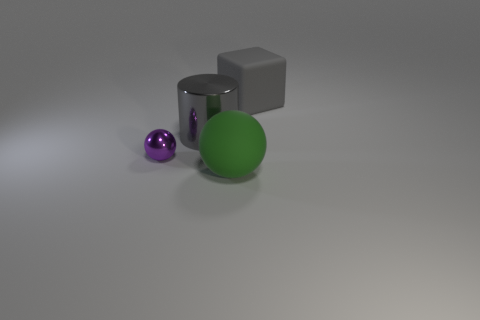Add 1 big gray matte cubes. How many objects exist? 5 Subtract all cylinders. How many objects are left? 3 Add 2 gray matte cubes. How many gray matte cubes are left? 3 Add 1 tiny things. How many tiny things exist? 2 Subtract 0 blue spheres. How many objects are left? 4 Subtract all big things. Subtract all large gray matte things. How many objects are left? 0 